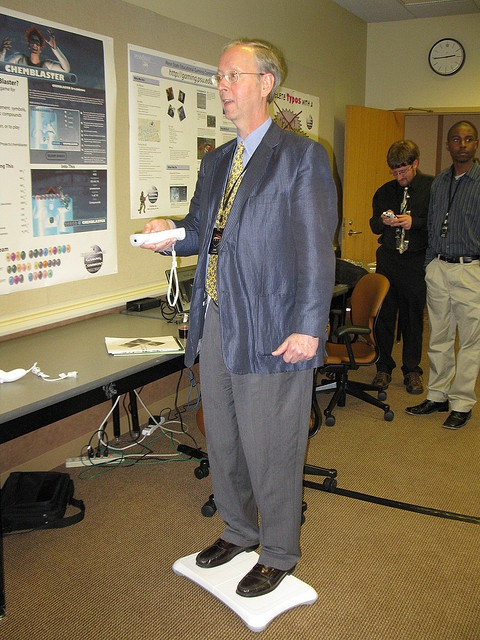Describe the objects in this image and their specific colors. I can see people in gray, tan, and black tones, people in gray, black, tan, and olive tones, people in gray, black, maroon, and brown tones, chair in gray, black, maroon, and olive tones, and handbag in gray, black, and maroon tones in this image. 